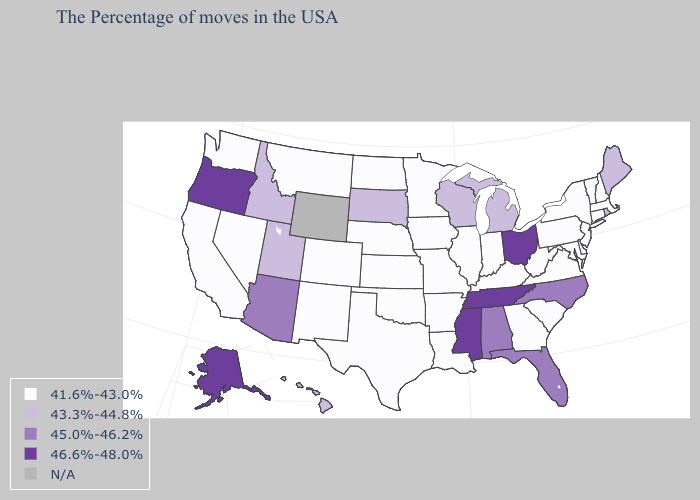What is the highest value in the USA?
Keep it brief. 46.6%-48.0%. What is the value of Arkansas?
Give a very brief answer. 41.6%-43.0%. What is the highest value in states that border South Dakota?
Short answer required. 41.6%-43.0%. Name the states that have a value in the range 41.6%-43.0%?
Answer briefly. Massachusetts, New Hampshire, Vermont, Connecticut, New York, New Jersey, Delaware, Maryland, Pennsylvania, Virginia, South Carolina, West Virginia, Georgia, Kentucky, Indiana, Illinois, Louisiana, Missouri, Arkansas, Minnesota, Iowa, Kansas, Nebraska, Oklahoma, Texas, North Dakota, Colorado, New Mexico, Montana, Nevada, California, Washington. Which states have the highest value in the USA?
Answer briefly. Ohio, Tennessee, Mississippi, Oregon, Alaska. Does Wisconsin have the highest value in the MidWest?
Short answer required. No. Among the states that border Mississippi , which have the highest value?
Concise answer only. Tennessee. Which states have the lowest value in the USA?
Be succinct. Massachusetts, New Hampshire, Vermont, Connecticut, New York, New Jersey, Delaware, Maryland, Pennsylvania, Virginia, South Carolina, West Virginia, Georgia, Kentucky, Indiana, Illinois, Louisiana, Missouri, Arkansas, Minnesota, Iowa, Kansas, Nebraska, Oklahoma, Texas, North Dakota, Colorado, New Mexico, Montana, Nevada, California, Washington. Which states have the lowest value in the USA?
Give a very brief answer. Massachusetts, New Hampshire, Vermont, Connecticut, New York, New Jersey, Delaware, Maryland, Pennsylvania, Virginia, South Carolina, West Virginia, Georgia, Kentucky, Indiana, Illinois, Louisiana, Missouri, Arkansas, Minnesota, Iowa, Kansas, Nebraska, Oklahoma, Texas, North Dakota, Colorado, New Mexico, Montana, Nevada, California, Washington. Does Tennessee have the highest value in the USA?
Be succinct. Yes. Does the first symbol in the legend represent the smallest category?
Short answer required. Yes. Name the states that have a value in the range 46.6%-48.0%?
Be succinct. Ohio, Tennessee, Mississippi, Oregon, Alaska. What is the lowest value in the USA?
Write a very short answer. 41.6%-43.0%. Which states have the highest value in the USA?
Concise answer only. Ohio, Tennessee, Mississippi, Oregon, Alaska. 